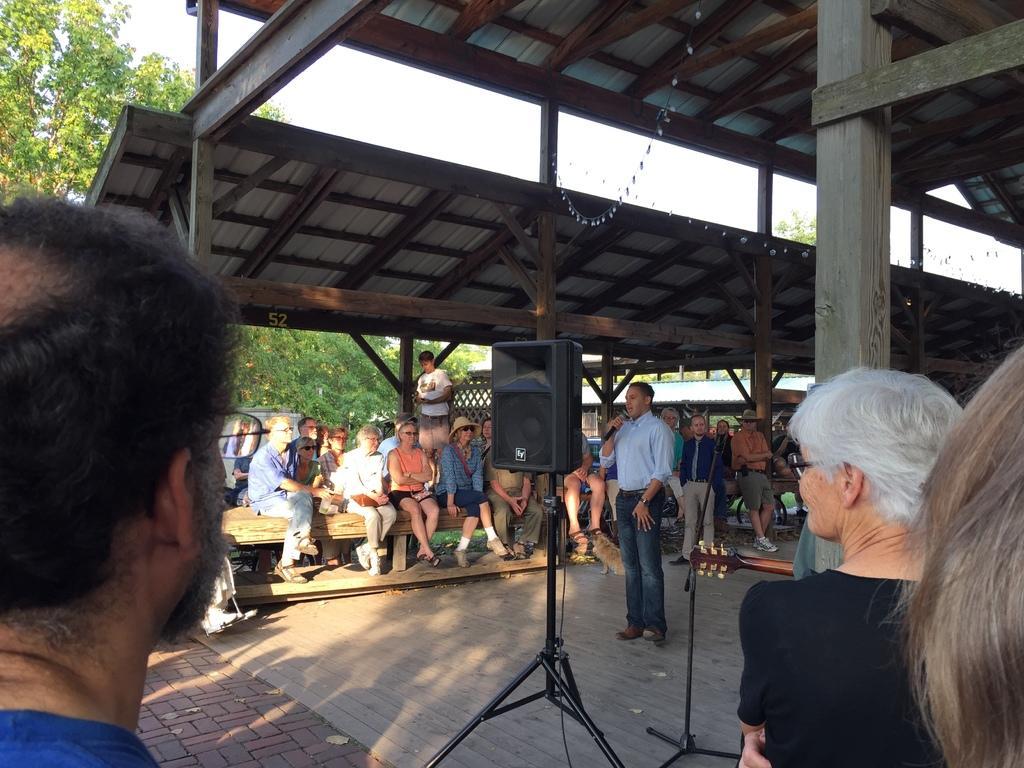In one or two sentences, can you explain what this image depicts? In this image we can see some sheds with pillars, some people are sitting, one microphone stand, one speaker with wire on the black stand, one musical instrument, some people are standing, two people are walking, some people are holding some objects, some dried leaves on the floor, some trees on the ground, some wires with small lights, one dog, one man standing in the middle holding a microphone and singing. At the top there is the sky. 